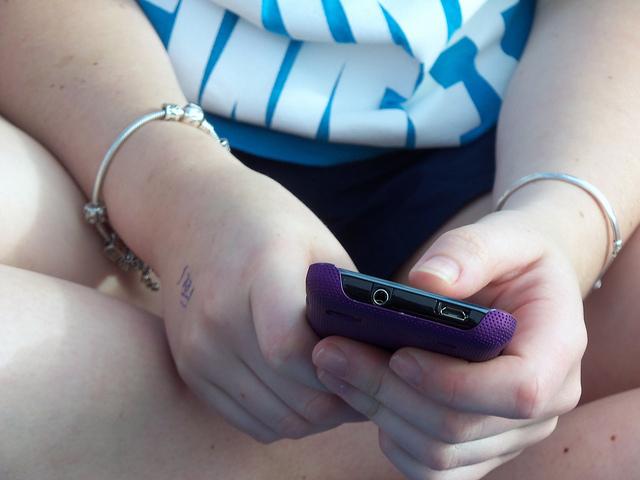Does this person have a tattoo?
Write a very short answer. No. How many bracelets do you see?
Be succinct. 2. Is the person under 20 years old?
Keep it brief. Yes. 